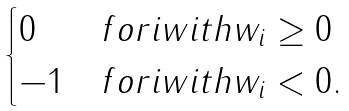Convert formula to latex. <formula><loc_0><loc_0><loc_500><loc_500>\begin{cases} 0 & f o r i w i t h w _ { i } \geq 0 \\ - 1 & f o r i w i t h w _ { i } < 0 . \\ \end{cases}</formula> 